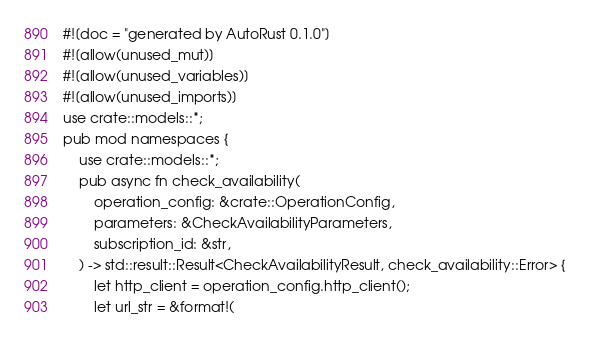Convert code to text. <code><loc_0><loc_0><loc_500><loc_500><_Rust_>#![doc = "generated by AutoRust 0.1.0"]
#![allow(unused_mut)]
#![allow(unused_variables)]
#![allow(unused_imports)]
use crate::models::*;
pub mod namespaces {
    use crate::models::*;
    pub async fn check_availability(
        operation_config: &crate::OperationConfig,
        parameters: &CheckAvailabilityParameters,
        subscription_id: &str,
    ) -> std::result::Result<CheckAvailabilityResult, check_availability::Error> {
        let http_client = operation_config.http_client();
        let url_str = &format!(</code> 